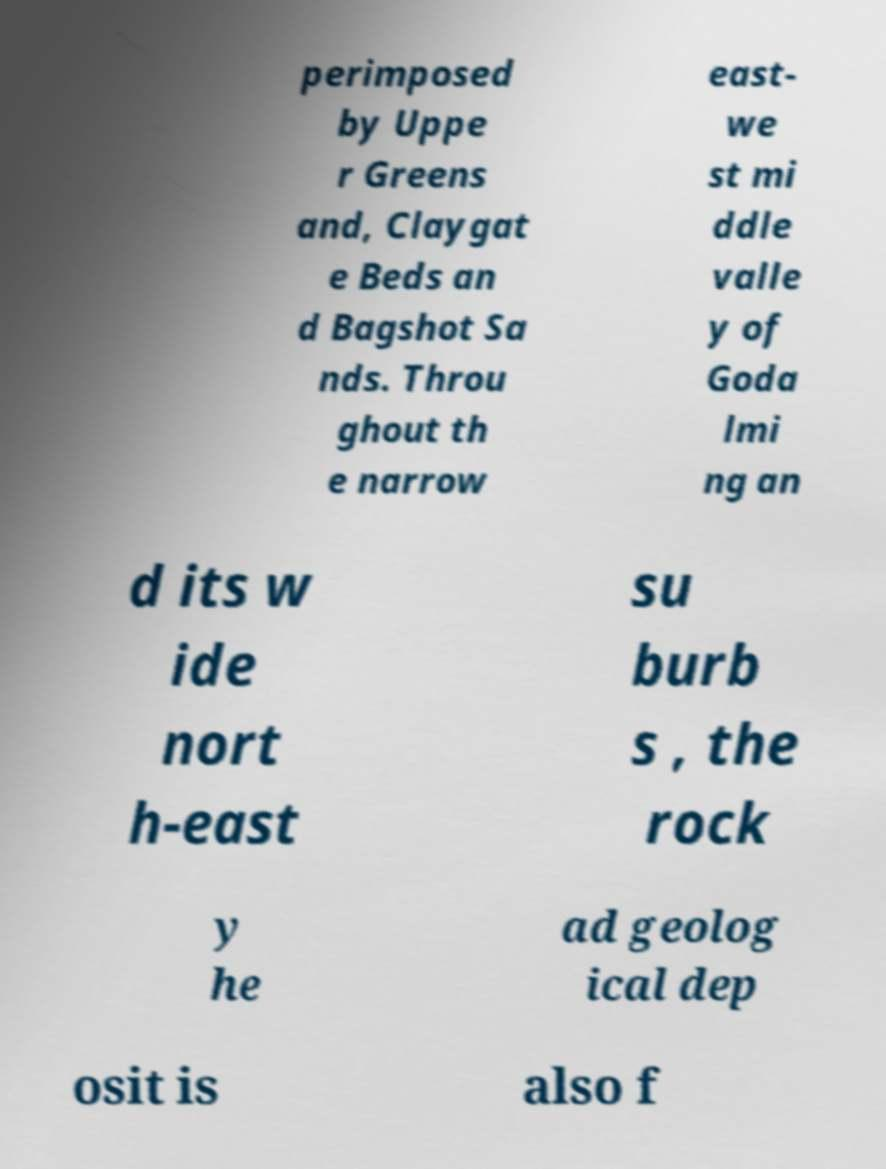There's text embedded in this image that I need extracted. Can you transcribe it verbatim? perimposed by Uppe r Greens and, Claygat e Beds an d Bagshot Sa nds. Throu ghout th e narrow east- we st mi ddle valle y of Goda lmi ng an d its w ide nort h-east su burb s , the rock y he ad geolog ical dep osit is also f 